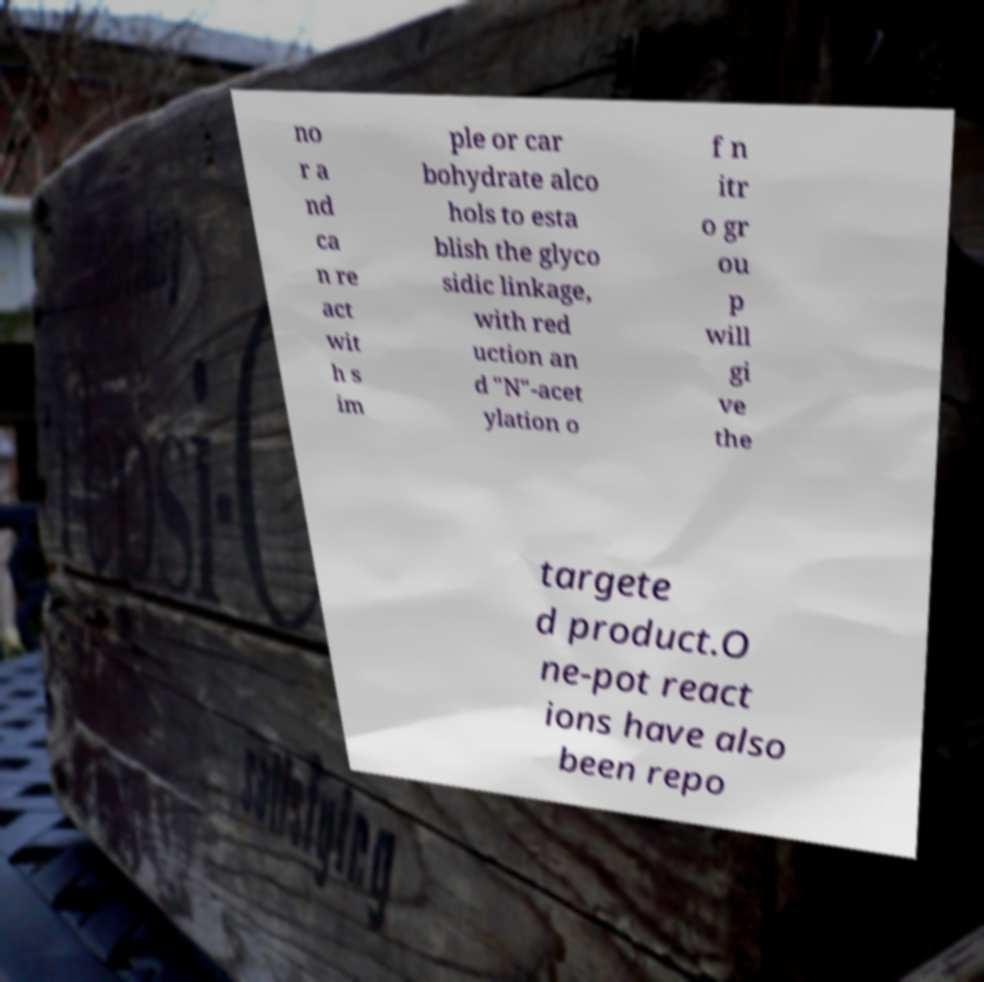For documentation purposes, I need the text within this image transcribed. Could you provide that? no r a nd ca n re act wit h s im ple or car bohydrate alco hols to esta blish the glyco sidic linkage, with red uction an d "N"-acet ylation o f n itr o gr ou p will gi ve the targete d product.O ne-pot react ions have also been repo 